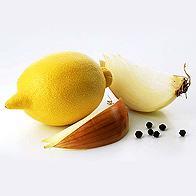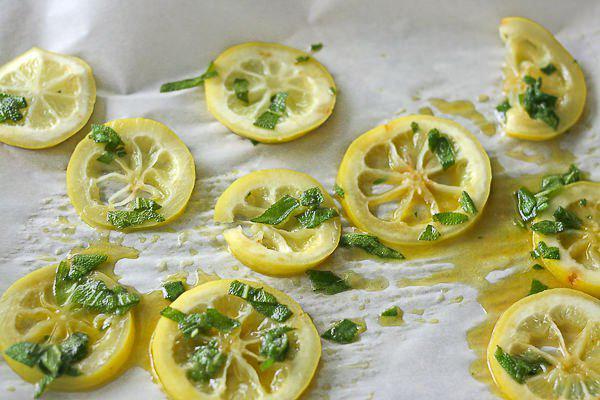The first image is the image on the left, the second image is the image on the right. Given the left and right images, does the statement "One image includes whole and half lemons." hold true? Answer yes or no. No. 